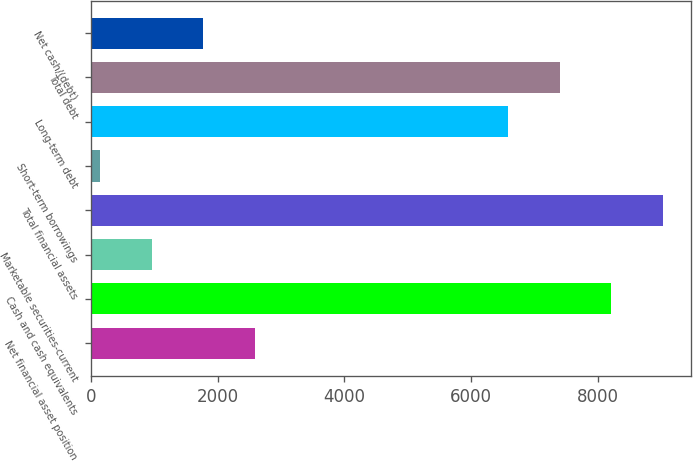Convert chart. <chart><loc_0><loc_0><loc_500><loc_500><bar_chart><fcel>Net financial asset position<fcel>Cash and cash equivalents<fcel>Marketable securities-current<fcel>Total financial assets<fcel>Short-term borrowings<fcel>Long-term debt<fcel>Total debt<fcel>Net cash/(debt)<nl><fcel>2587.3<fcel>8207.2<fcel>965.1<fcel>9018.3<fcel>154<fcel>6585<fcel>7396.1<fcel>1776.2<nl></chart> 